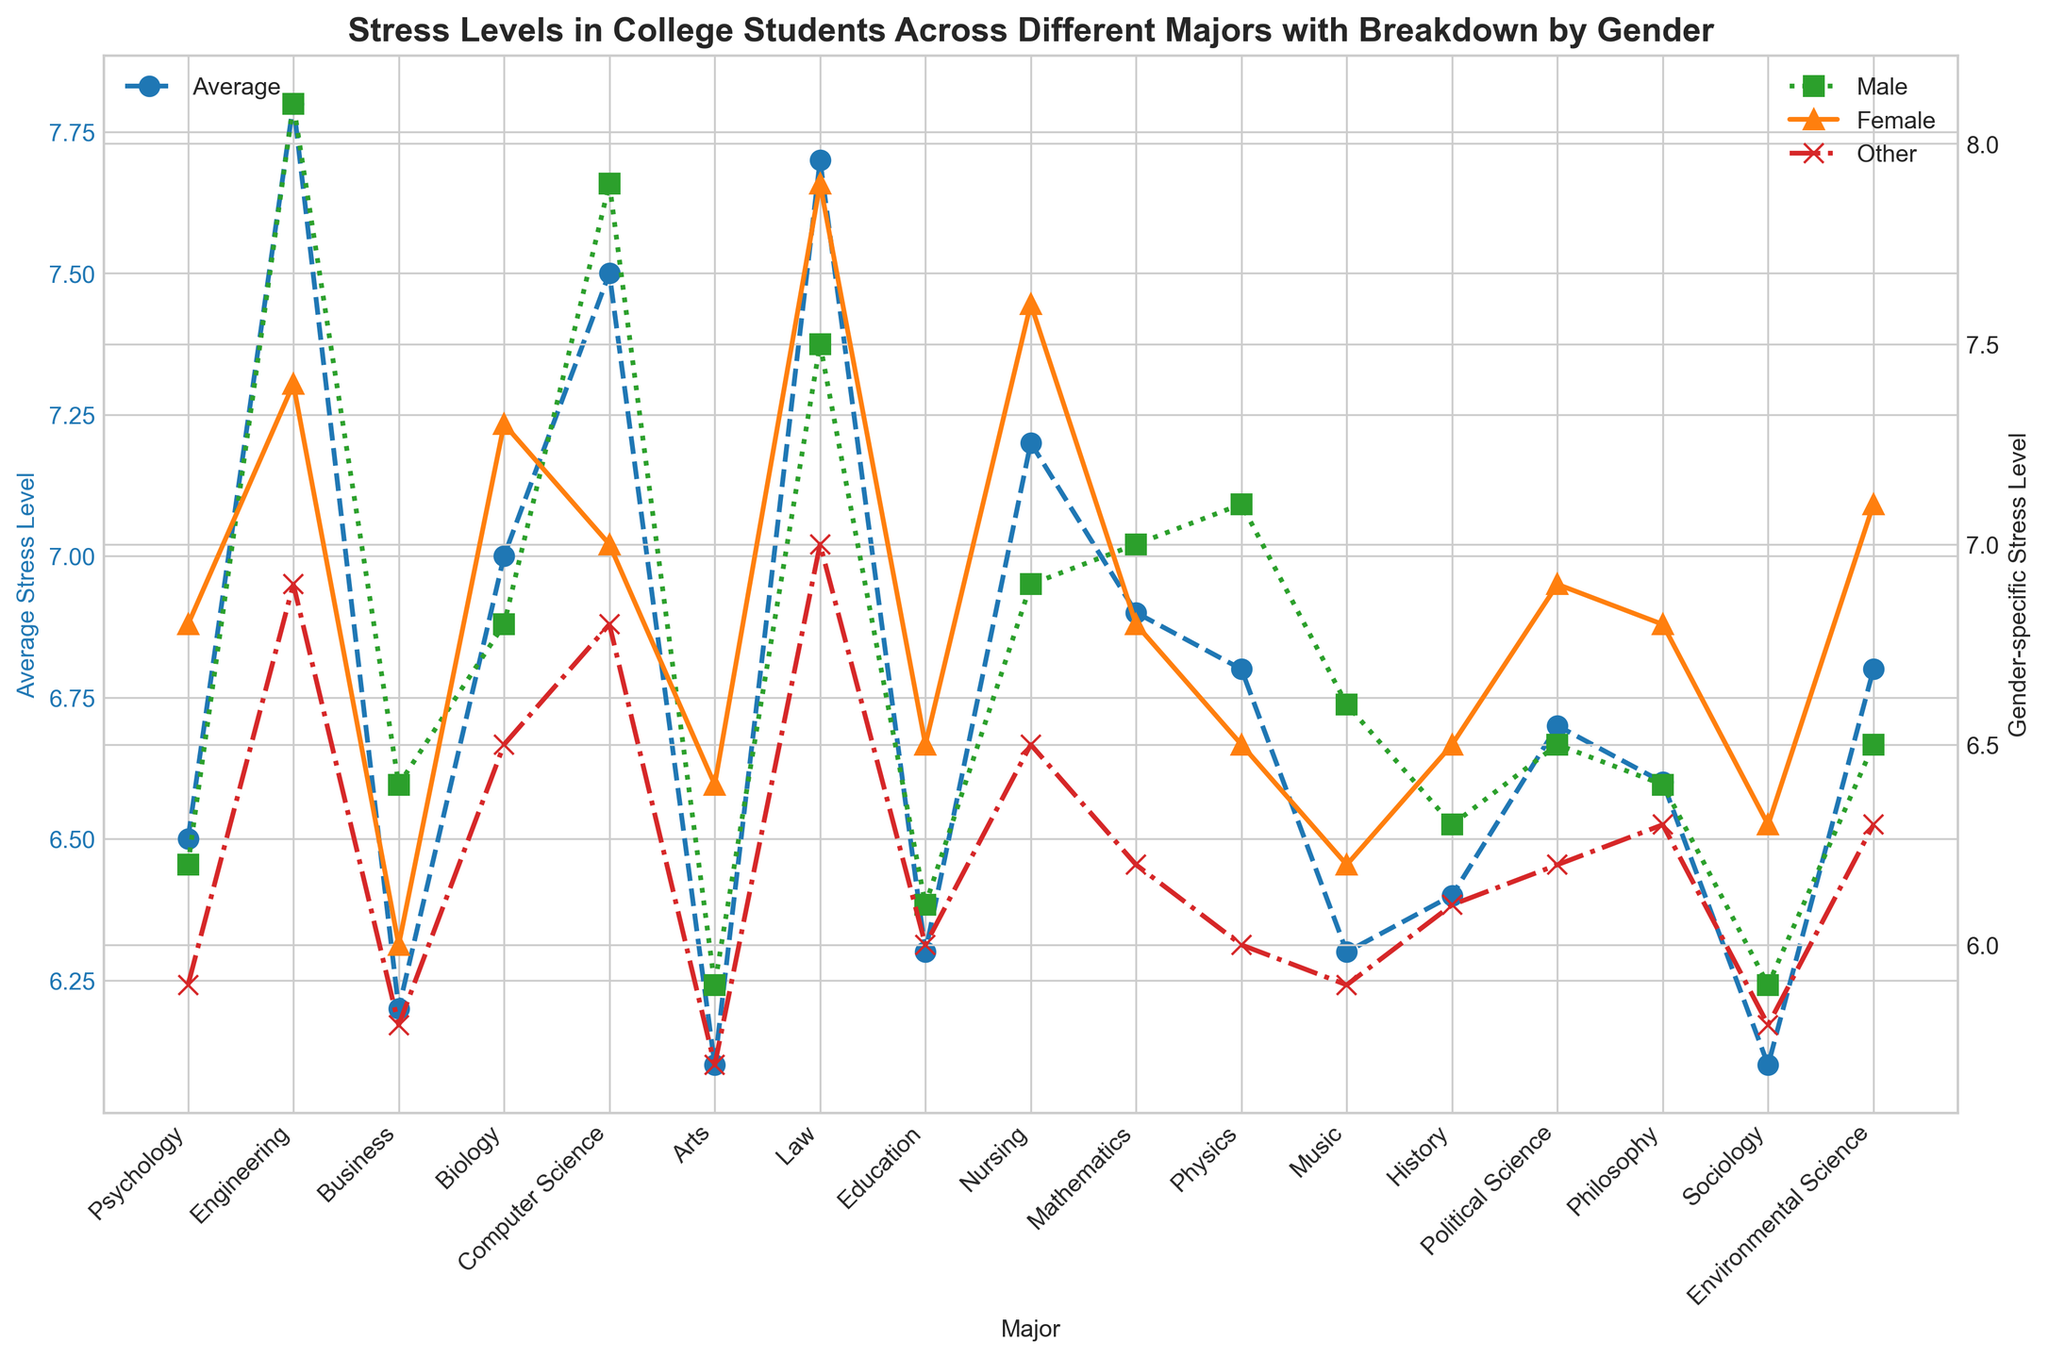Which major has the highest average stress level? Scan the legends to identify different markers and then observe the height of the lines across different majors. The tallest marker in the overall average stress level line will show the highest value.
Answer: Engineering What is the difference in average stress level between Psychology and Nursing? Identify the average stress levels for Psychology and Nursing from the blue line and subtract the smaller value from the larger one.
Answer: 0.7 Which gender in Engineering has higher stress levels, male or female? Look at the markers specific to gender in Engineering. The green (Male) marker is higher than the orange (Female) marker for Engineering.
Answer: Male How does the stress level for Other gender in Political Science compare to Sociology? Compare the height of the red (Other) markers for Political Science and Sociology. The Political Science marker is higher than the Sociology marker.
Answer: Higher in Political Science What is the average stress level for males in Computer Science and Business? Identify the green markers for males in Computer Science and Business and calculate the average by adding both and dividing by 2. (7.9 + 6.4) / 2 = 7.15
Answer: 7.15 Is there any major where the stress level for females is equal to that for males? Compare the orange and green markers across all majors to see if any overlap. Biology (both are 6.8) is an instance.
Answer: Biology Which major shows the smallest difference between male and female stress levels? Subtract male stress levels from female stress levels for each major, and find the one with the smallest difference. Mathematics shows 0.2 (7.0 - 6.8).
Answer: Mathematics What is the trend observed in the average stress levels from Psychology to Law? Follow the blue line from Psychology to Law. Generally, the line shows an increasing trend.
Answer: Increasing What is the combined average stress level for all genders in Arts? To find the combined average, add the stress levels of Male, Female, and Other in Arts and divide by 3. (5.9 + 6.4 + 5.7) / 3 = 6.0
Answer: 6.0 Does the major Nursing have a higher stress level for males or females, and by how much? Observe the green and orange markers for Nursing. The orange (Female) marker is higher. Subtract the male value from the female value: 7.6 - 6.9 = 0.7.
Answer: Females, 0.7 